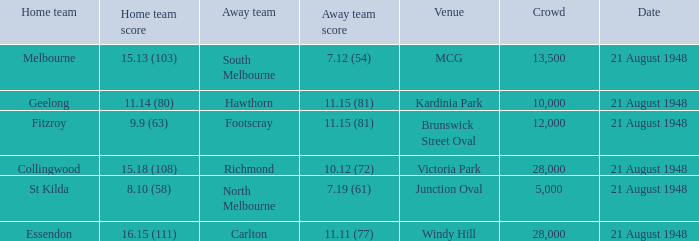If the Away team is north melbourne, what's the Home team score? 8.10 (58). 